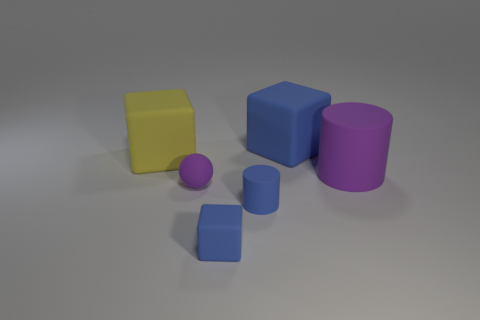What could be the potential uses for these 3D objects in a visual project? These 3D objects could be used as placeholders or as basic elements in a graphic design project, animation, or game development. They could serve to draft the layout of a scene, to test lighting and color schemes, or to prototype more intricate models that will be added to the scene at a later stage of development. 